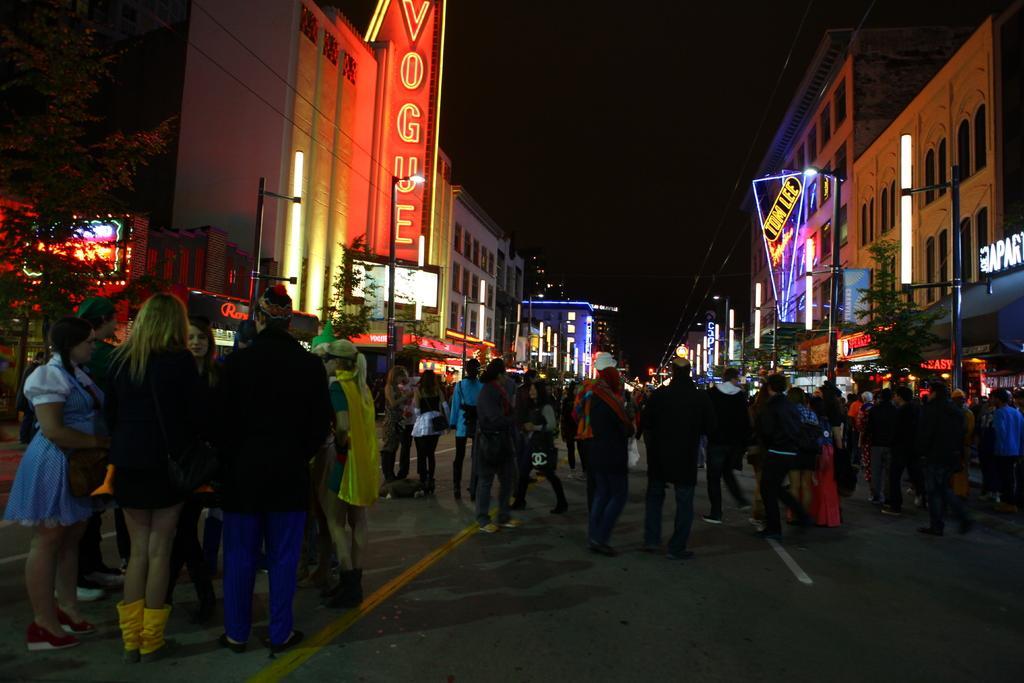Describe this image in one or two sentences. In this image there are group of people standing and on the right side and left side there are buildings, trees, poles, lights. And at the bottom there is a road. 